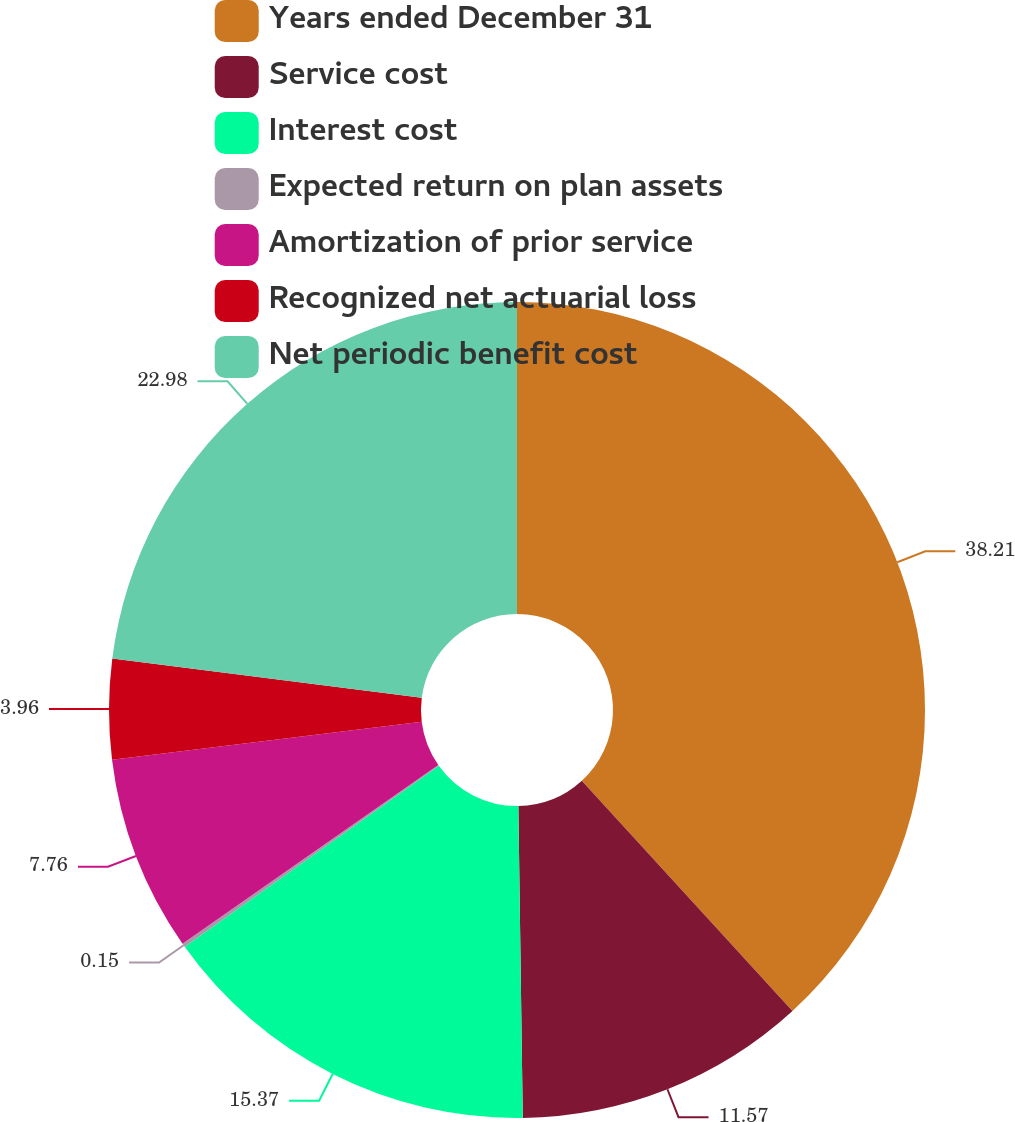Convert chart. <chart><loc_0><loc_0><loc_500><loc_500><pie_chart><fcel>Years ended December 31<fcel>Service cost<fcel>Interest cost<fcel>Expected return on plan assets<fcel>Amortization of prior service<fcel>Recognized net actuarial loss<fcel>Net periodic benefit cost<nl><fcel>38.2%<fcel>11.57%<fcel>15.37%<fcel>0.15%<fcel>7.76%<fcel>3.96%<fcel>22.98%<nl></chart> 